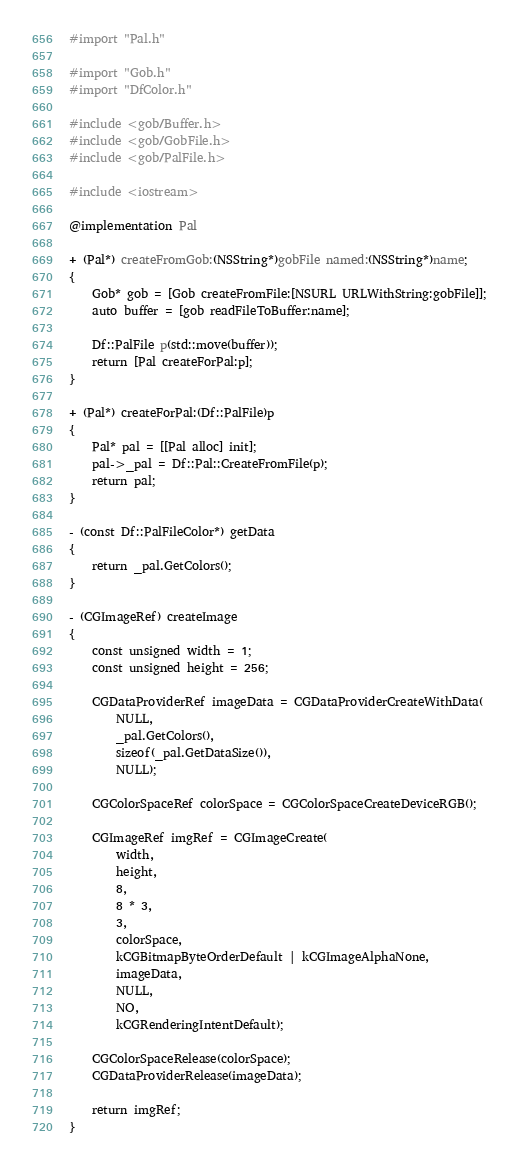Convert code to text. <code><loc_0><loc_0><loc_500><loc_500><_ObjectiveC_>#import "Pal.h"

#import "Gob.h"
#import "DfColor.h"

#include <gob/Buffer.h>
#include <gob/GobFile.h>
#include <gob/PalFile.h>

#include <iostream>

@implementation Pal

+ (Pal*) createFromGob:(NSString*)gobFile named:(NSString*)name;
{
    Gob* gob = [Gob createFromFile:[NSURL URLWithString:gobFile]];
    auto buffer = [gob readFileToBuffer:name];

    Df::PalFile p(std::move(buffer));
    return [Pal createForPal:p];
}

+ (Pal*) createForPal:(Df::PalFile)p
{
    Pal* pal = [[Pal alloc] init];
    pal->_pal = Df::Pal::CreateFromFile(p);
    return pal;
}

- (const Df::PalFileColor*) getData
{
    return _pal.GetColors();
}

- (CGImageRef) createImage
{
    const unsigned width = 1;
    const unsigned height = 256;

    CGDataProviderRef imageData = CGDataProviderCreateWithData(
        NULL,
        _pal.GetColors(),
        sizeof(_pal.GetDataSize()),
        NULL);
    
    CGColorSpaceRef colorSpace = CGColorSpaceCreateDeviceRGB();
    
    CGImageRef imgRef = CGImageCreate(
        width,
        height,
        8,
        8 * 3,
        3,
        colorSpace,
        kCGBitmapByteOrderDefault | kCGImageAlphaNone,
        imageData,
        NULL,
        NO,
        kCGRenderingIntentDefault);
    
    CGColorSpaceRelease(colorSpace);
    CGDataProviderRelease(imageData);

    return imgRef;
}
</code> 